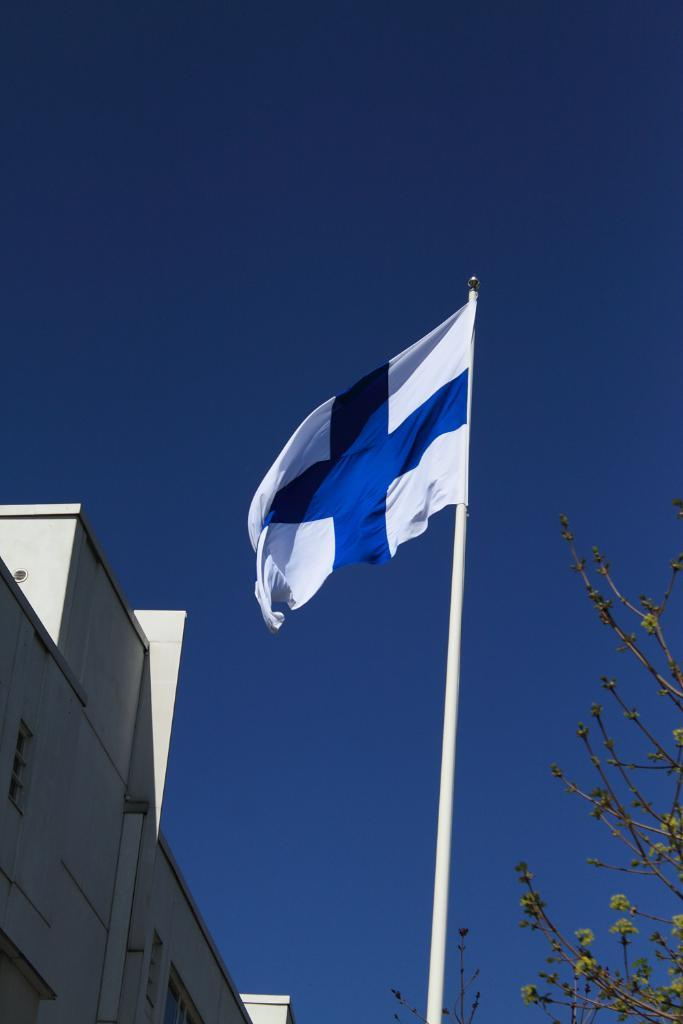What is the main subject in the center of the image? There is a flag in the center of the image. What structure can be seen to the left side of the image? There is a building to the left side of the image. What is visible at the top of the image? There is sky visible at the top of the image. What type of vegetation is on the right side of the image? There is a tree to the right side of the image. How many apples are hanging from the tree in the image? There are no apples present in the image; it only features a tree. What type of debt is being discussed in the image? There is no mention of debt in the image; it only features a flag, building, sky, and tree. 